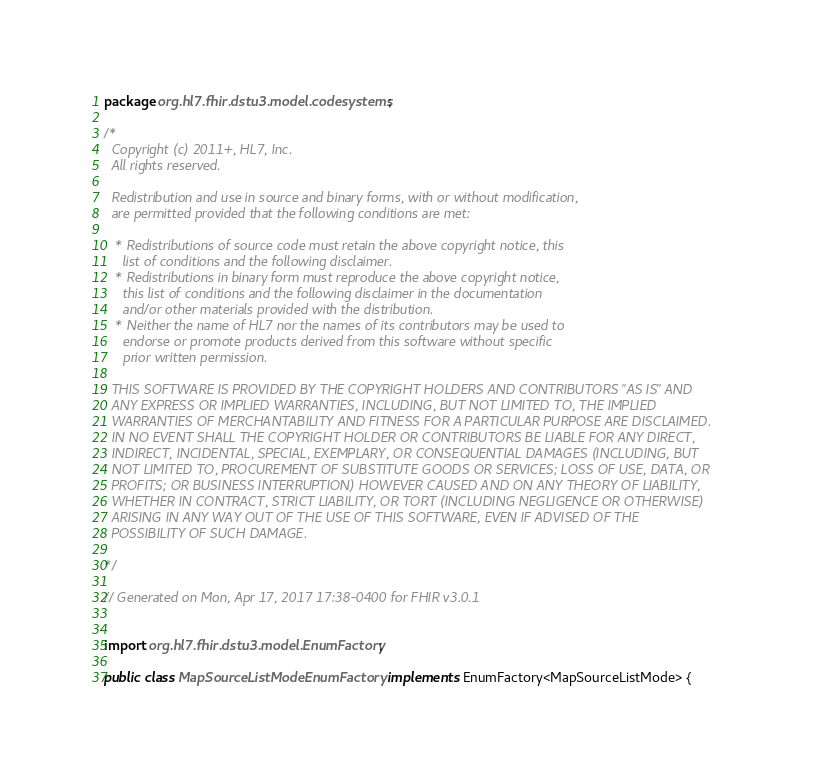<code> <loc_0><loc_0><loc_500><loc_500><_Java_>package org.hl7.fhir.dstu3.model.codesystems;

/*
  Copyright (c) 2011+, HL7, Inc.
  All rights reserved.
  
  Redistribution and use in source and binary forms, with or without modification, 
  are permitted provided that the following conditions are met:
  
   * Redistributions of source code must retain the above copyright notice, this 
     list of conditions and the following disclaimer.
   * Redistributions in binary form must reproduce the above copyright notice, 
     this list of conditions and the following disclaimer in the documentation 
     and/or other materials provided with the distribution.
   * Neither the name of HL7 nor the names of its contributors may be used to 
     endorse or promote products derived from this software without specific 
     prior written permission.
  
  THIS SOFTWARE IS PROVIDED BY THE COPYRIGHT HOLDERS AND CONTRIBUTORS "AS IS" AND 
  ANY EXPRESS OR IMPLIED WARRANTIES, INCLUDING, BUT NOT LIMITED TO, THE IMPLIED 
  WARRANTIES OF MERCHANTABILITY AND FITNESS FOR A PARTICULAR PURPOSE ARE DISCLAIMED. 
  IN NO EVENT SHALL THE COPYRIGHT HOLDER OR CONTRIBUTORS BE LIABLE FOR ANY DIRECT, 
  INDIRECT, INCIDENTAL, SPECIAL, EXEMPLARY, OR CONSEQUENTIAL DAMAGES (INCLUDING, BUT 
  NOT LIMITED TO, PROCUREMENT OF SUBSTITUTE GOODS OR SERVICES; LOSS OF USE, DATA, OR 
  PROFITS; OR BUSINESS INTERRUPTION) HOWEVER CAUSED AND ON ANY THEORY OF LIABILITY, 
  WHETHER IN CONTRACT, STRICT LIABILITY, OR TORT (INCLUDING NEGLIGENCE OR OTHERWISE) 
  ARISING IN ANY WAY OUT OF THE USE OF THIS SOFTWARE, EVEN IF ADVISED OF THE 
  POSSIBILITY OF SUCH DAMAGE.
  
*/

// Generated on Mon, Apr 17, 2017 17:38-0400 for FHIR v3.0.1


import org.hl7.fhir.dstu3.model.EnumFactory;

public class MapSourceListModeEnumFactory implements EnumFactory<MapSourceListMode> {
</code> 